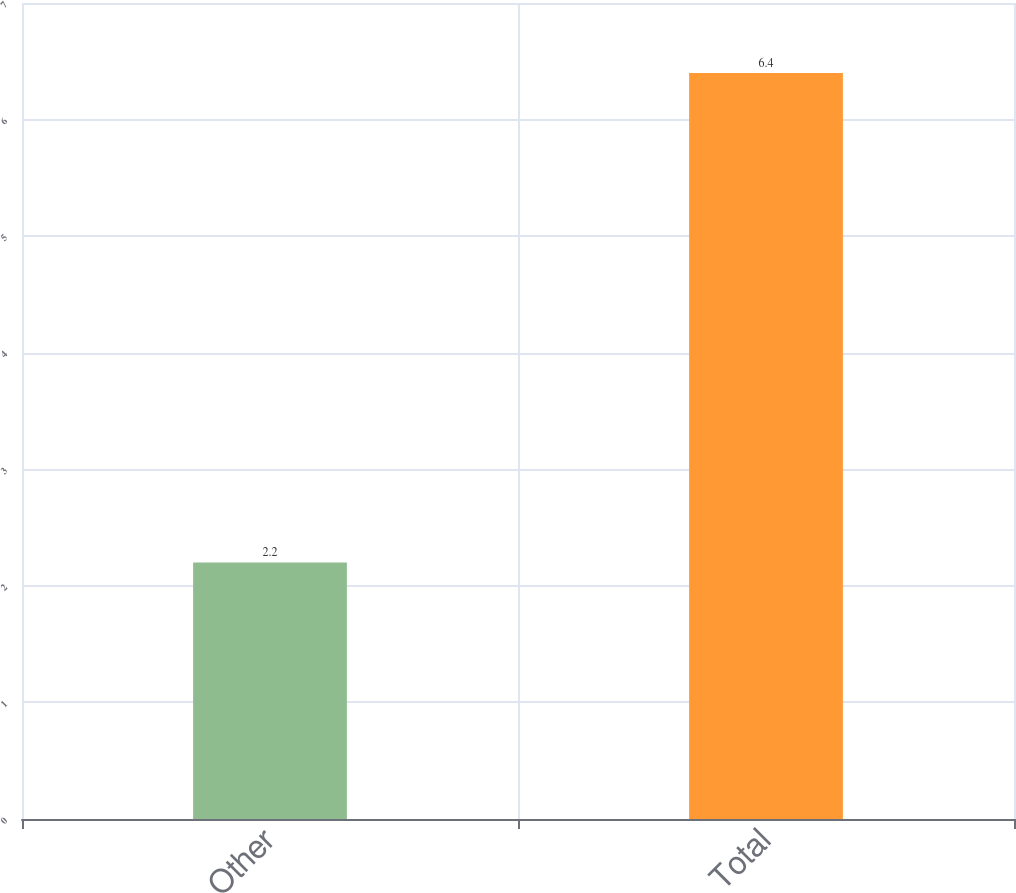Convert chart. <chart><loc_0><loc_0><loc_500><loc_500><bar_chart><fcel>Other<fcel>Total<nl><fcel>2.2<fcel>6.4<nl></chart> 